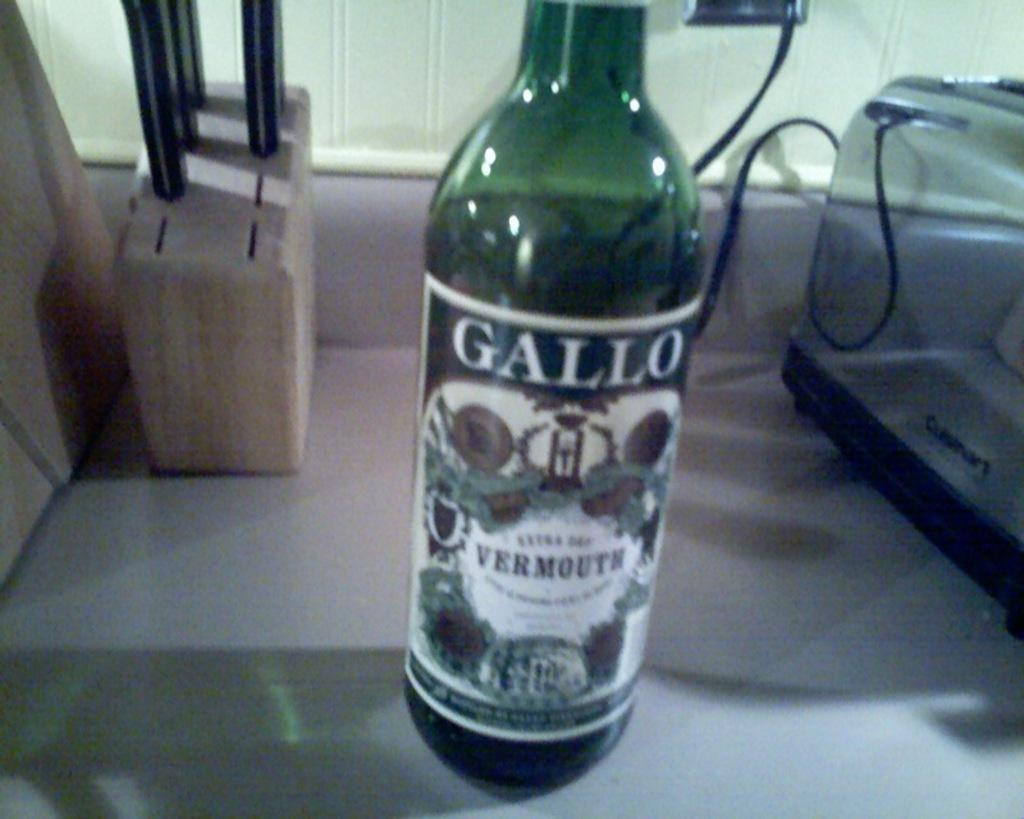<image>
Summarize the visual content of the image. a green bottle with a label on it that says 'gallo' at the top 